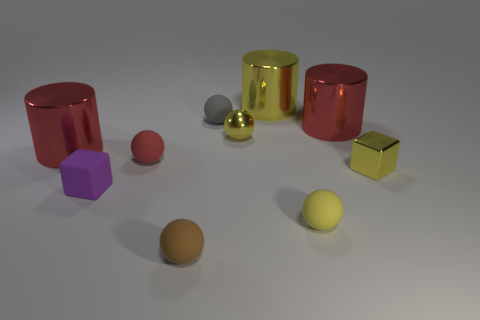What is the color of the tiny rubber cube?
Give a very brief answer. Purple. What number of large things are either yellow things or green rubber cylinders?
Provide a succinct answer. 1. There is a small metal thing on the left side of the yellow metallic cylinder; is it the same color as the large object that is right of the large yellow thing?
Ensure brevity in your answer.  No. What number of other objects are there of the same color as the tiny metal sphere?
Give a very brief answer. 3. What is the shape of the big red object that is to the left of the small red matte sphere?
Your response must be concise. Cylinder. Is the number of large red cylinders less than the number of cylinders?
Provide a short and direct response. Yes. Do the yellow object that is in front of the purple matte thing and the small brown object have the same material?
Your answer should be compact. Yes. Are there any small metallic things right of the yellow matte object?
Ensure brevity in your answer.  Yes. There is a metal cylinder that is to the right of the metal cylinder that is behind the red shiny object that is right of the yellow rubber thing; what is its color?
Offer a very short reply. Red. The brown matte thing that is the same size as the metal cube is what shape?
Provide a succinct answer. Sphere. 